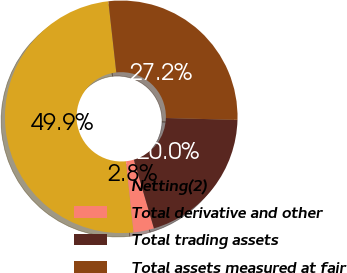Convert chart to OTSL. <chart><loc_0><loc_0><loc_500><loc_500><pie_chart><fcel>Netting(2)<fcel>Total derivative and other<fcel>Total trading assets<fcel>Total assets measured at fair<nl><fcel>49.93%<fcel>2.84%<fcel>20.04%<fcel>27.19%<nl></chart> 